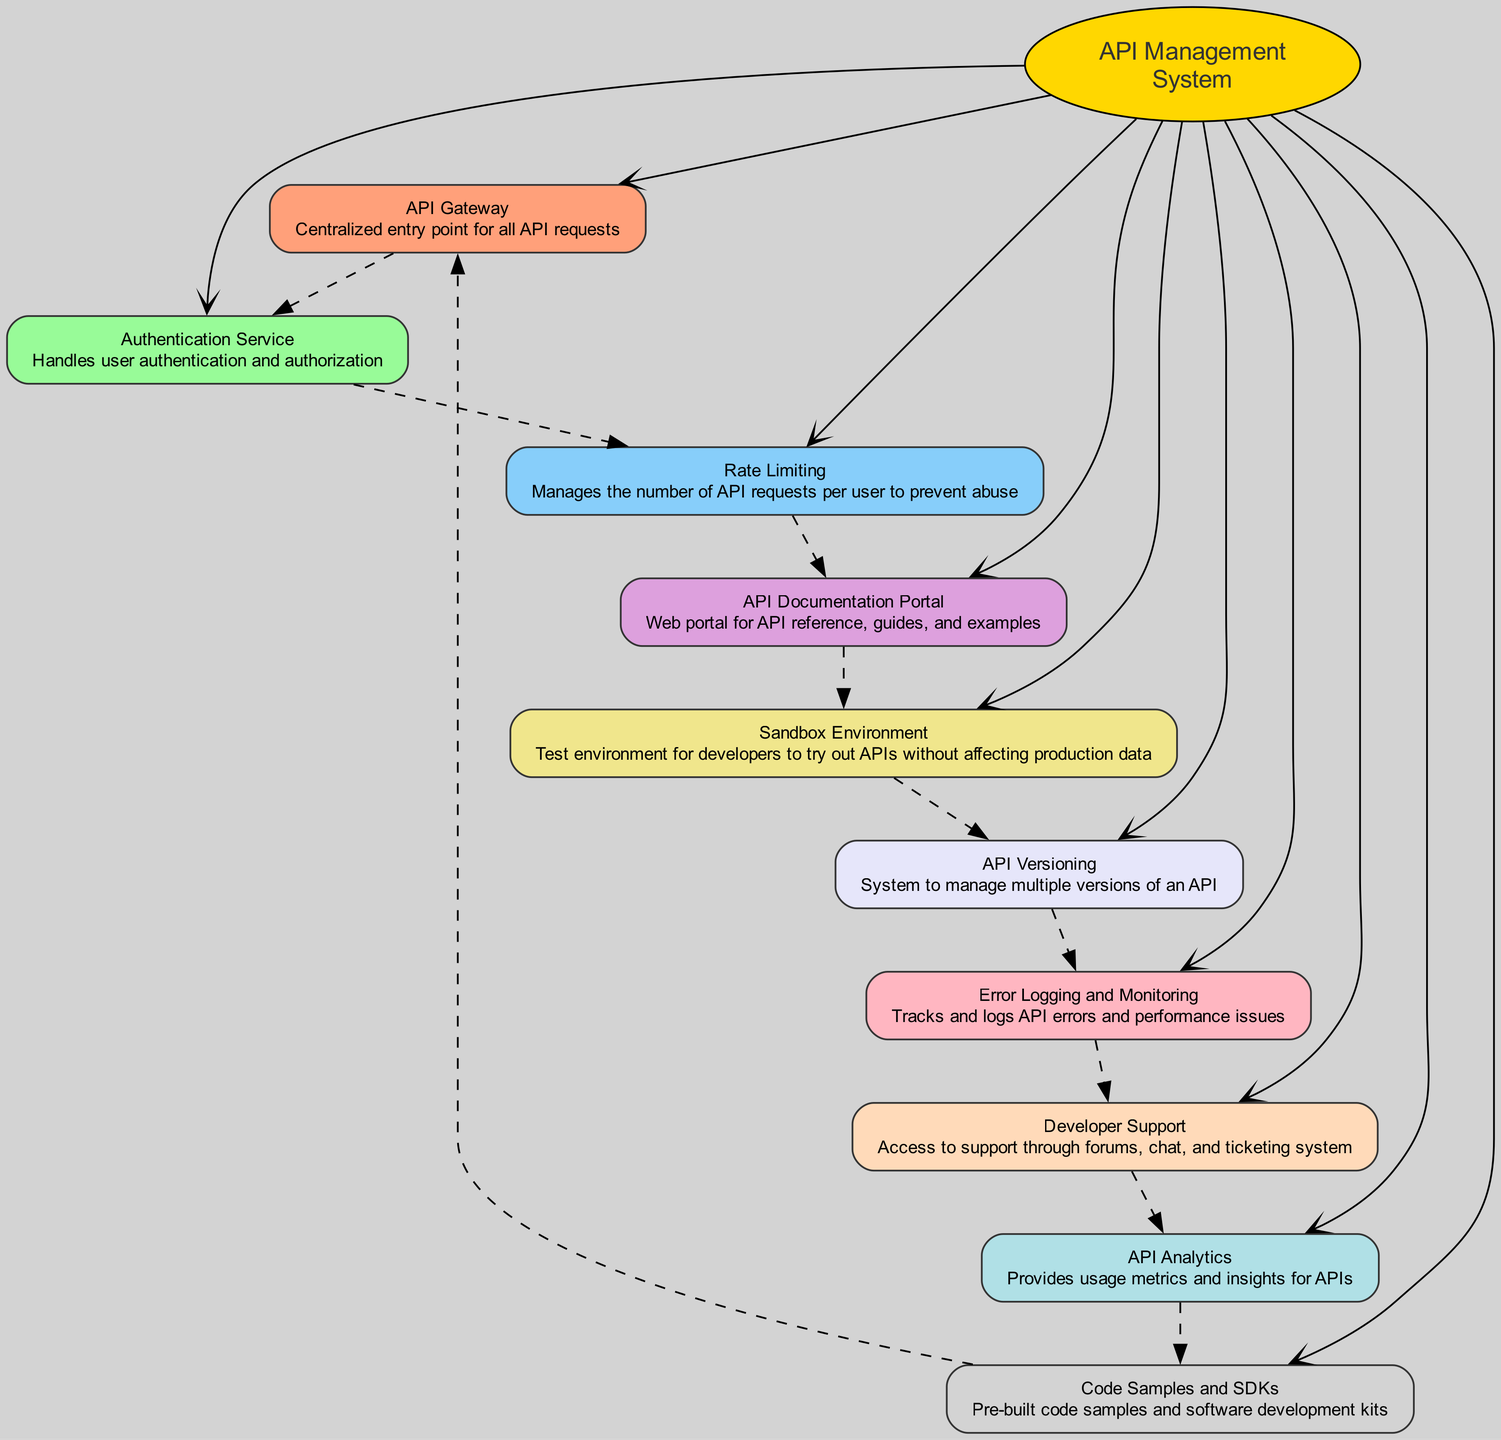What is the total number of components in the diagram? The diagram lists 10 components, as identified in the provided data under the 'elements' section. Counting each listed component gives us this total.
Answer: 10 Which component serves as the centralized entry point for all API requests? The component named "API Gateway" is described as the centralized entry point for all API requests in the diagram.
Answer: API Gateway What does the "Authentication Service" handle? The description of the "Authentication Service" clearly states that it handles user authentication and authorization, making this the answer to the question.
Answer: User authentication and authorization How many components directly connect to the "API Management System"? In the diagram, the central node "API Management System" has edges connecting to each of the 10 components. Therefore, there are 10 direct connections to the central node.
Answer: 10 What system is responsible for managing multiple API versions? The description directly indicates that "API Versioning" is the system tasked with managing multiple versions of an API, providing a straightforward answer.
Answer: API Versioning What type of environment does the "Sandbox Environment" represent? The description of the "Sandbox Environment" mentions it is a test environment for developers, which aligns with the question about its representation.
Answer: Test environment Which two components provide insights and usage metrics for APIs? By examining both "API Analytics" and "Error Logging and Monitoring," we conclude that together, they provide insights and usage metrics for APIs.
Answer: API Analytics and Error Logging and Monitoring What is the purpose of the "API Documentation Portal"? The "API Documentation Portal" is described as a web portal for API reference, guides, and examples, which clearly defines its purpose.
Answer: Web portal for API reference, guides, and examples Which component is associated with supporting developers through various channels? The "Developer Support" component is designated for providing access to support through forums, chat, and a ticketing system that is aimed directly at assisting developers.
Answer: Developer Support What is the function of the "Rate Limiting" component? The "Rate Limiting" component explicitly states that it manages the number of API requests per user to prevent abuse, thereby defining its function clearly.
Answer: Manages API request numbers per user to prevent abuse 